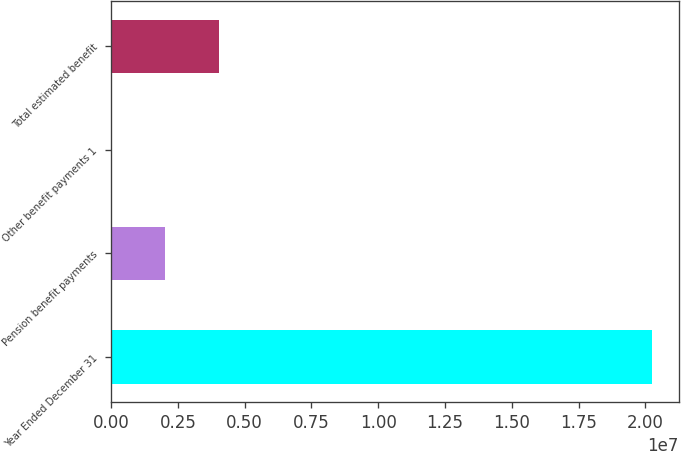Convert chart. <chart><loc_0><loc_0><loc_500><loc_500><bar_chart><fcel>Year Ended December 31<fcel>Pension benefit payments<fcel>Other benefit payments 1<fcel>Total estimated benefit<nl><fcel>2.0242e+07<fcel>2.02443e+06<fcel>250<fcel>4.04861e+06<nl></chart> 